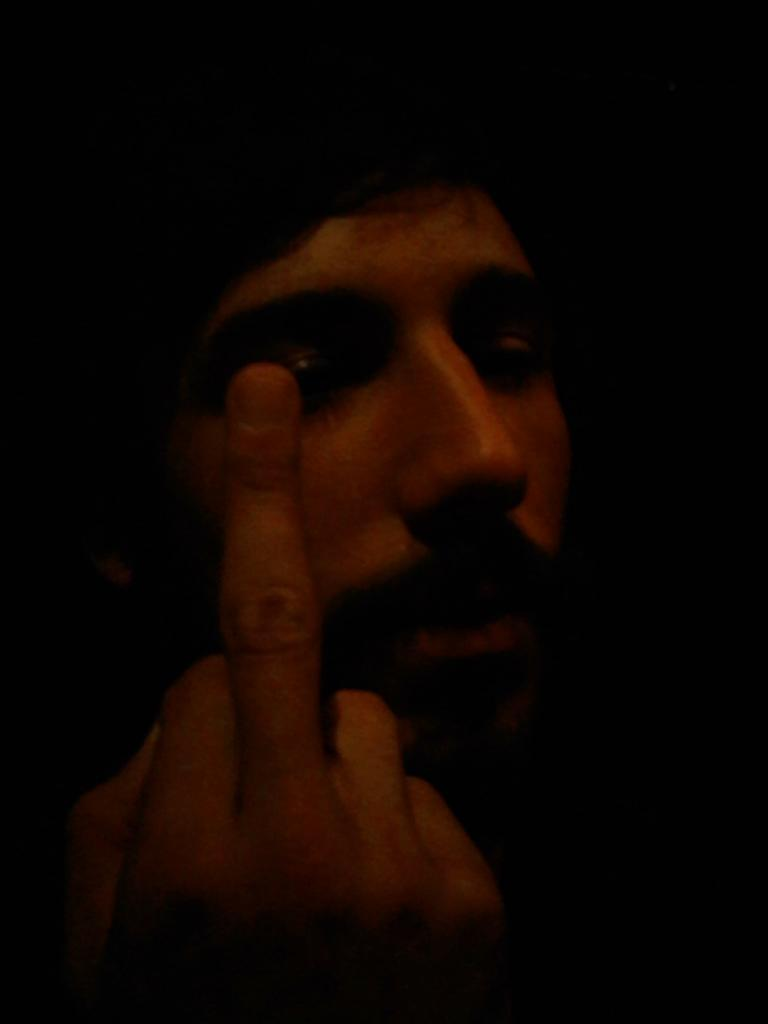What is the main subject of the image? There is a person in the image. What is the person doing in the image? The person is showing his finger. Can you describe the background of the image? The background of the image has a dark view. What type of ice can be seen falling in the image? There is no ice or sleet visible in the image; it only features a person showing his finger against a dark background. 